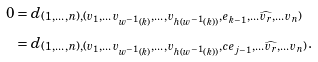Convert formula to latex. <formula><loc_0><loc_0><loc_500><loc_500>0 & = d _ { ( 1 , \dots , n ) , ( v _ { 1 } , \dots v _ { w ^ { - 1 } ( k ) } , \dots , v _ { h ( w ^ { - 1 } ( k ) ) } , e _ { k - 1 } , \dots \widehat { v _ { r } } , \dots v _ { n } ) } \\ & = d _ { ( 1 , \dots , n ) , ( v _ { 1 } , \dots v _ { w ^ { - 1 } ( k ) } , \dots , v _ { h ( w ^ { - 1 } ( k ) ) } , c e _ { j - 1 } , \dots \widehat { v _ { r } } , \dots v _ { n } ) } .</formula> 